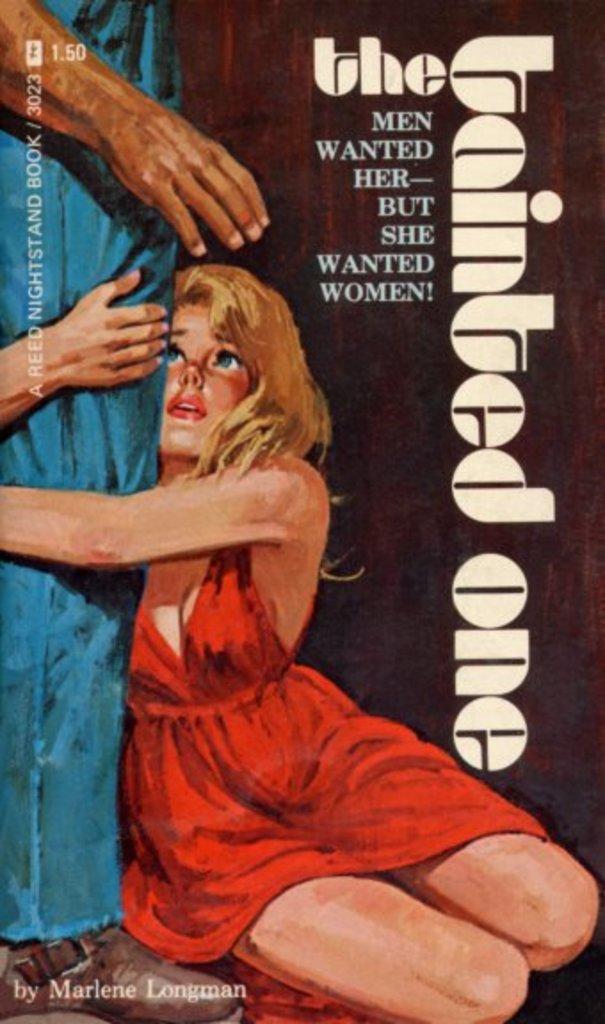What did the girl want, according to the poster?
Offer a very short reply. Women. Who is the author of this book?
Your response must be concise. Marlene longman. 